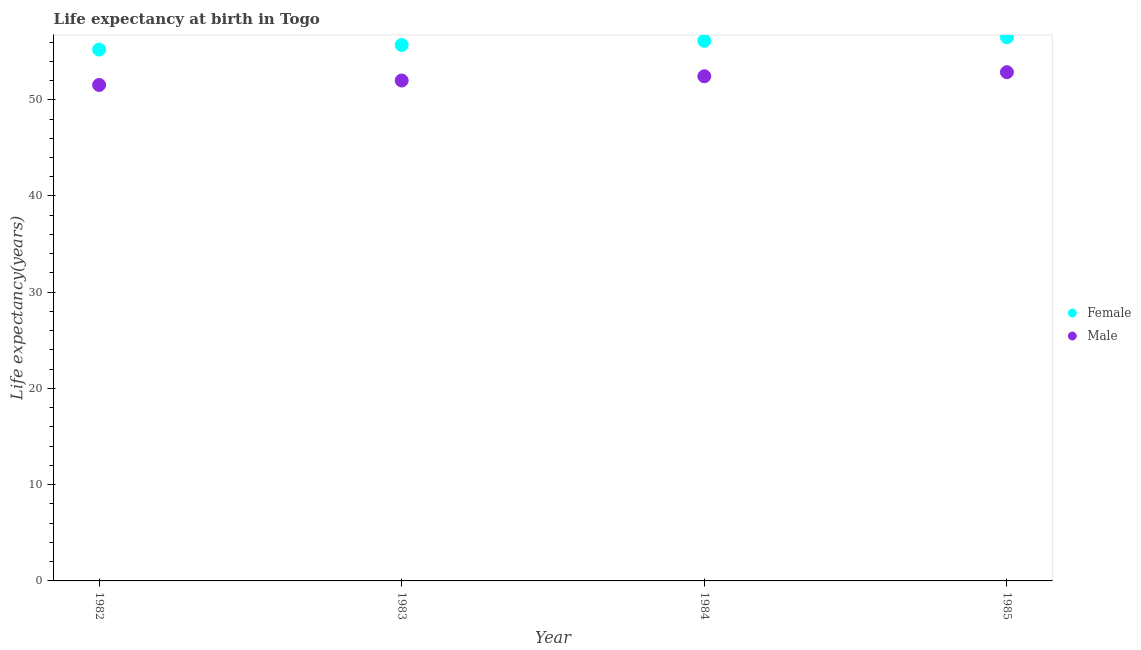What is the life expectancy(female) in 1984?
Keep it short and to the point. 56.13. Across all years, what is the maximum life expectancy(female)?
Offer a terse response. 56.49. Across all years, what is the minimum life expectancy(male)?
Make the answer very short. 51.54. In which year was the life expectancy(female) maximum?
Ensure brevity in your answer.  1985. What is the total life expectancy(female) in the graph?
Your answer should be very brief. 223.53. What is the difference between the life expectancy(male) in 1983 and that in 1984?
Ensure brevity in your answer.  -0.44. What is the difference between the life expectancy(female) in 1985 and the life expectancy(male) in 1984?
Give a very brief answer. 4.05. What is the average life expectancy(male) per year?
Your answer should be very brief. 52.21. In the year 1982, what is the difference between the life expectancy(male) and life expectancy(female)?
Ensure brevity in your answer.  -3.68. What is the ratio of the life expectancy(male) in 1984 to that in 1985?
Make the answer very short. 0.99. Is the difference between the life expectancy(female) in 1982 and 1984 greater than the difference between the life expectancy(male) in 1982 and 1984?
Offer a very short reply. No. What is the difference between the highest and the second highest life expectancy(male)?
Keep it short and to the point. 0.42. What is the difference between the highest and the lowest life expectancy(male)?
Make the answer very short. 1.33. In how many years, is the life expectancy(male) greater than the average life expectancy(male) taken over all years?
Your answer should be very brief. 2. Does the life expectancy(female) monotonically increase over the years?
Offer a very short reply. Yes. How many dotlines are there?
Keep it short and to the point. 2. Does the graph contain grids?
Your answer should be compact. No. Where does the legend appear in the graph?
Your response must be concise. Center right. How are the legend labels stacked?
Keep it short and to the point. Vertical. What is the title of the graph?
Offer a terse response. Life expectancy at birth in Togo. What is the label or title of the Y-axis?
Your response must be concise. Life expectancy(years). What is the Life expectancy(years) in Female in 1982?
Make the answer very short. 55.21. What is the Life expectancy(years) in Male in 1982?
Provide a succinct answer. 51.54. What is the Life expectancy(years) of Female in 1983?
Your response must be concise. 55.7. What is the Life expectancy(years) of Male in 1983?
Offer a terse response. 52. What is the Life expectancy(years) of Female in 1984?
Offer a very short reply. 56.13. What is the Life expectancy(years) of Male in 1984?
Give a very brief answer. 52.44. What is the Life expectancy(years) of Female in 1985?
Offer a terse response. 56.49. What is the Life expectancy(years) of Male in 1985?
Offer a very short reply. 52.86. Across all years, what is the maximum Life expectancy(years) in Female?
Offer a terse response. 56.49. Across all years, what is the maximum Life expectancy(years) in Male?
Offer a very short reply. 52.86. Across all years, what is the minimum Life expectancy(years) of Female?
Keep it short and to the point. 55.21. Across all years, what is the minimum Life expectancy(years) in Male?
Keep it short and to the point. 51.54. What is the total Life expectancy(years) of Female in the graph?
Keep it short and to the point. 223.53. What is the total Life expectancy(years) of Male in the graph?
Make the answer very short. 208.84. What is the difference between the Life expectancy(years) in Female in 1982 and that in 1983?
Your response must be concise. -0.48. What is the difference between the Life expectancy(years) in Male in 1982 and that in 1983?
Offer a terse response. -0.46. What is the difference between the Life expectancy(years) in Female in 1982 and that in 1984?
Offer a terse response. -0.91. What is the difference between the Life expectancy(years) in Male in 1982 and that in 1984?
Offer a very short reply. -0.91. What is the difference between the Life expectancy(years) of Female in 1982 and that in 1985?
Keep it short and to the point. -1.28. What is the difference between the Life expectancy(years) in Male in 1982 and that in 1985?
Your answer should be very brief. -1.33. What is the difference between the Life expectancy(years) of Female in 1983 and that in 1984?
Keep it short and to the point. -0.43. What is the difference between the Life expectancy(years) in Male in 1983 and that in 1984?
Keep it short and to the point. -0.44. What is the difference between the Life expectancy(years) of Female in 1983 and that in 1985?
Ensure brevity in your answer.  -0.8. What is the difference between the Life expectancy(years) of Male in 1983 and that in 1985?
Provide a succinct answer. -0.86. What is the difference between the Life expectancy(years) in Female in 1984 and that in 1985?
Give a very brief answer. -0.37. What is the difference between the Life expectancy(years) in Male in 1984 and that in 1985?
Your answer should be very brief. -0.42. What is the difference between the Life expectancy(years) of Female in 1982 and the Life expectancy(years) of Male in 1983?
Offer a very short reply. 3.21. What is the difference between the Life expectancy(years) in Female in 1982 and the Life expectancy(years) in Male in 1984?
Your response must be concise. 2.77. What is the difference between the Life expectancy(years) in Female in 1982 and the Life expectancy(years) in Male in 1985?
Ensure brevity in your answer.  2.35. What is the difference between the Life expectancy(years) in Female in 1983 and the Life expectancy(years) in Male in 1984?
Offer a terse response. 3.25. What is the difference between the Life expectancy(years) in Female in 1983 and the Life expectancy(years) in Male in 1985?
Your response must be concise. 2.83. What is the difference between the Life expectancy(years) of Female in 1984 and the Life expectancy(years) of Male in 1985?
Your response must be concise. 3.26. What is the average Life expectancy(years) in Female per year?
Provide a short and direct response. 55.88. What is the average Life expectancy(years) of Male per year?
Keep it short and to the point. 52.21. In the year 1982, what is the difference between the Life expectancy(years) in Female and Life expectancy(years) in Male?
Your answer should be compact. 3.68. In the year 1983, what is the difference between the Life expectancy(years) in Female and Life expectancy(years) in Male?
Keep it short and to the point. 3.7. In the year 1984, what is the difference between the Life expectancy(years) of Female and Life expectancy(years) of Male?
Offer a very short reply. 3.69. In the year 1985, what is the difference between the Life expectancy(years) in Female and Life expectancy(years) in Male?
Offer a very short reply. 3.63. What is the ratio of the Life expectancy(years) in Female in 1982 to that in 1984?
Your answer should be very brief. 0.98. What is the ratio of the Life expectancy(years) of Male in 1982 to that in 1984?
Give a very brief answer. 0.98. What is the ratio of the Life expectancy(years) in Female in 1982 to that in 1985?
Provide a short and direct response. 0.98. What is the ratio of the Life expectancy(years) in Male in 1982 to that in 1985?
Keep it short and to the point. 0.97. What is the ratio of the Life expectancy(years) of Female in 1983 to that in 1984?
Ensure brevity in your answer.  0.99. What is the ratio of the Life expectancy(years) of Male in 1983 to that in 1984?
Your response must be concise. 0.99. What is the ratio of the Life expectancy(years) of Female in 1983 to that in 1985?
Provide a succinct answer. 0.99. What is the ratio of the Life expectancy(years) in Male in 1983 to that in 1985?
Provide a succinct answer. 0.98. What is the ratio of the Life expectancy(years) of Female in 1984 to that in 1985?
Keep it short and to the point. 0.99. What is the difference between the highest and the second highest Life expectancy(years) of Female?
Make the answer very short. 0.37. What is the difference between the highest and the second highest Life expectancy(years) in Male?
Ensure brevity in your answer.  0.42. What is the difference between the highest and the lowest Life expectancy(years) of Female?
Ensure brevity in your answer.  1.28. What is the difference between the highest and the lowest Life expectancy(years) in Male?
Ensure brevity in your answer.  1.33. 